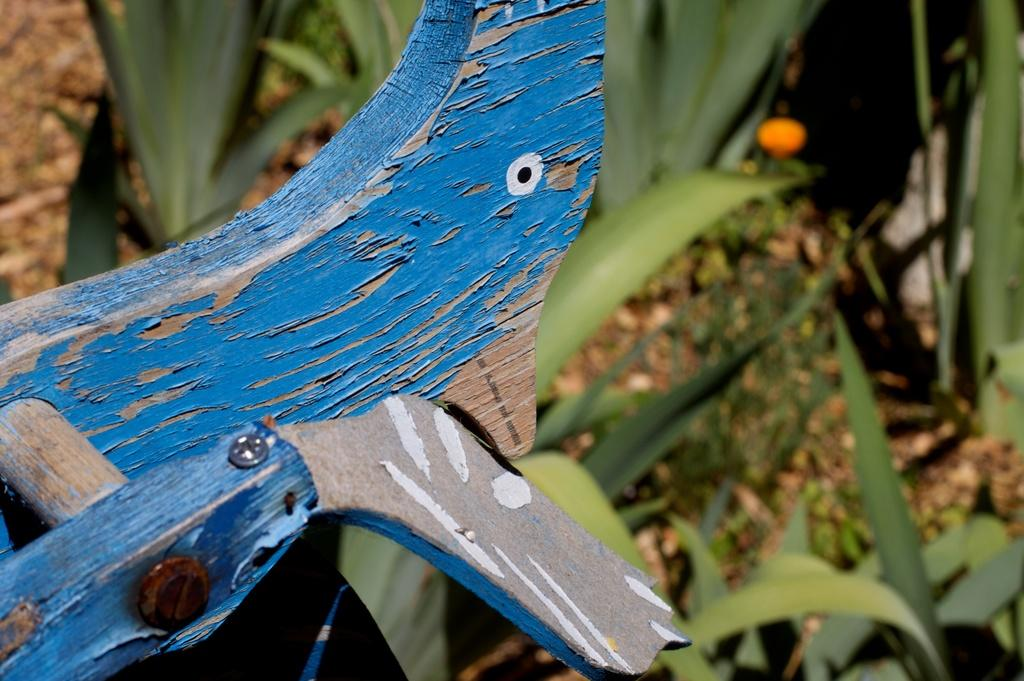What type of material is the wooden object made of in the image? The wooden object in the image is made of wood. What other elements can be seen in the image besides the wooden object? There are plants in the image. What type of police vehicle can be seen in the image? There is no police vehicle present in the image; it only features a wooden object and plants. What type of train can be seen in the image? There is no train present in the image; it only features a wooden object and plants. 